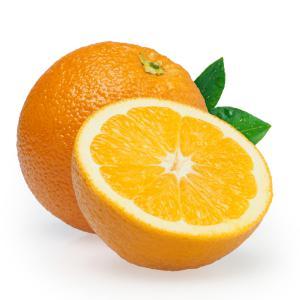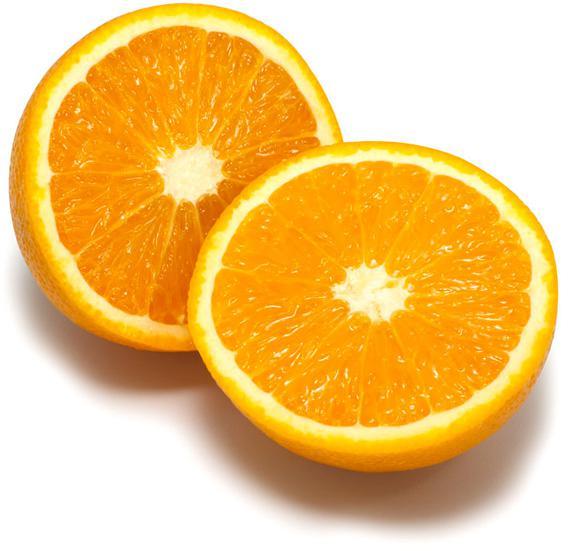The first image is the image on the left, the second image is the image on the right. For the images displayed, is the sentence "There is at least one unsliced orange." factually correct? Answer yes or no. Yes. 